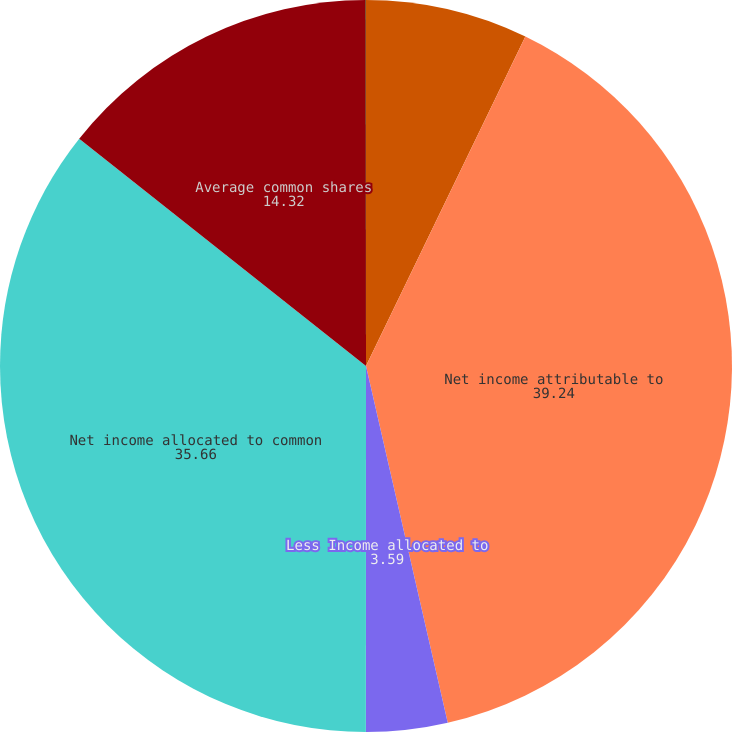Convert chart. <chart><loc_0><loc_0><loc_500><loc_500><pie_chart><fcel>Years Ended December 31<fcel>Net income attributable to<fcel>Less Income allocated to<fcel>Net income allocated to common<fcel>Average common shares<fcel>Common shares issuable (1)<nl><fcel>7.17%<fcel>39.24%<fcel>3.59%<fcel>35.66%<fcel>14.32%<fcel>0.01%<nl></chart> 